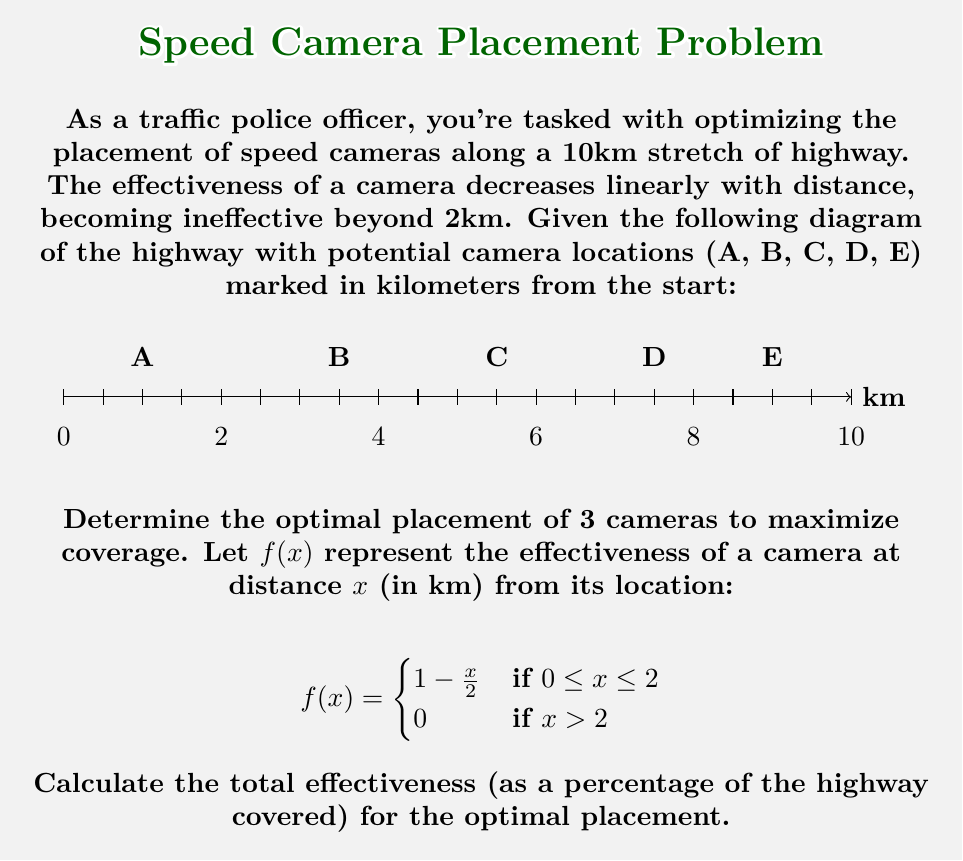What is the answer to this math problem? To solve this problem, we'll follow these steps:

1) First, we need to understand that the optimal placement will maximize the coverage while minimizing overlap.

2) Given the camera's 2km range, we can deduce that the optimal placement will have cameras spaced approximately 4km apart to cover the most area with minimal overlap.

3) Looking at the potential locations, we can see that A (1km), C (5.5km), and E (9km) are closest to this ideal spacing.

4) To calculate the effectiveness, we need to consider the coverage of each camera:

   For camera A (1km):
   - Covers 0-2km fully, and 2-3km partially
   - Effectiveness: $\int_0^2 (1 - \frac{x}{2}) dx + \int_0^1 (1 - \frac{x}{2}) dx = 2 + 0.75 = 2.75$

   For camera C (5.5km):
   - Covers 3.5-5.5km fully, and 5.5-7.5km partially
   - Effectiveness: $\int_0^2 (1 - \frac{x}{2}) dx = 2$

   For camera E (9km):
   - Covers 7-9km fully, and 9-10km partially
   - Effectiveness: $\int_0^2 (1 - \frac{x}{2}) dx + \int_0^1 (1 - \frac{x}{2}) dx = 2 + 0.75 = 2.75$

5) Total effectiveness: $2.75 + 2 + 2.75 = 7.5$ km

6) To express this as a percentage of the 10km highway:
   $\frac{7.5}{10} \times 100\% = 75\%$

Therefore, the optimal placement of cameras at A, C, and E provides 75% coverage of the highway.
Answer: 75% 